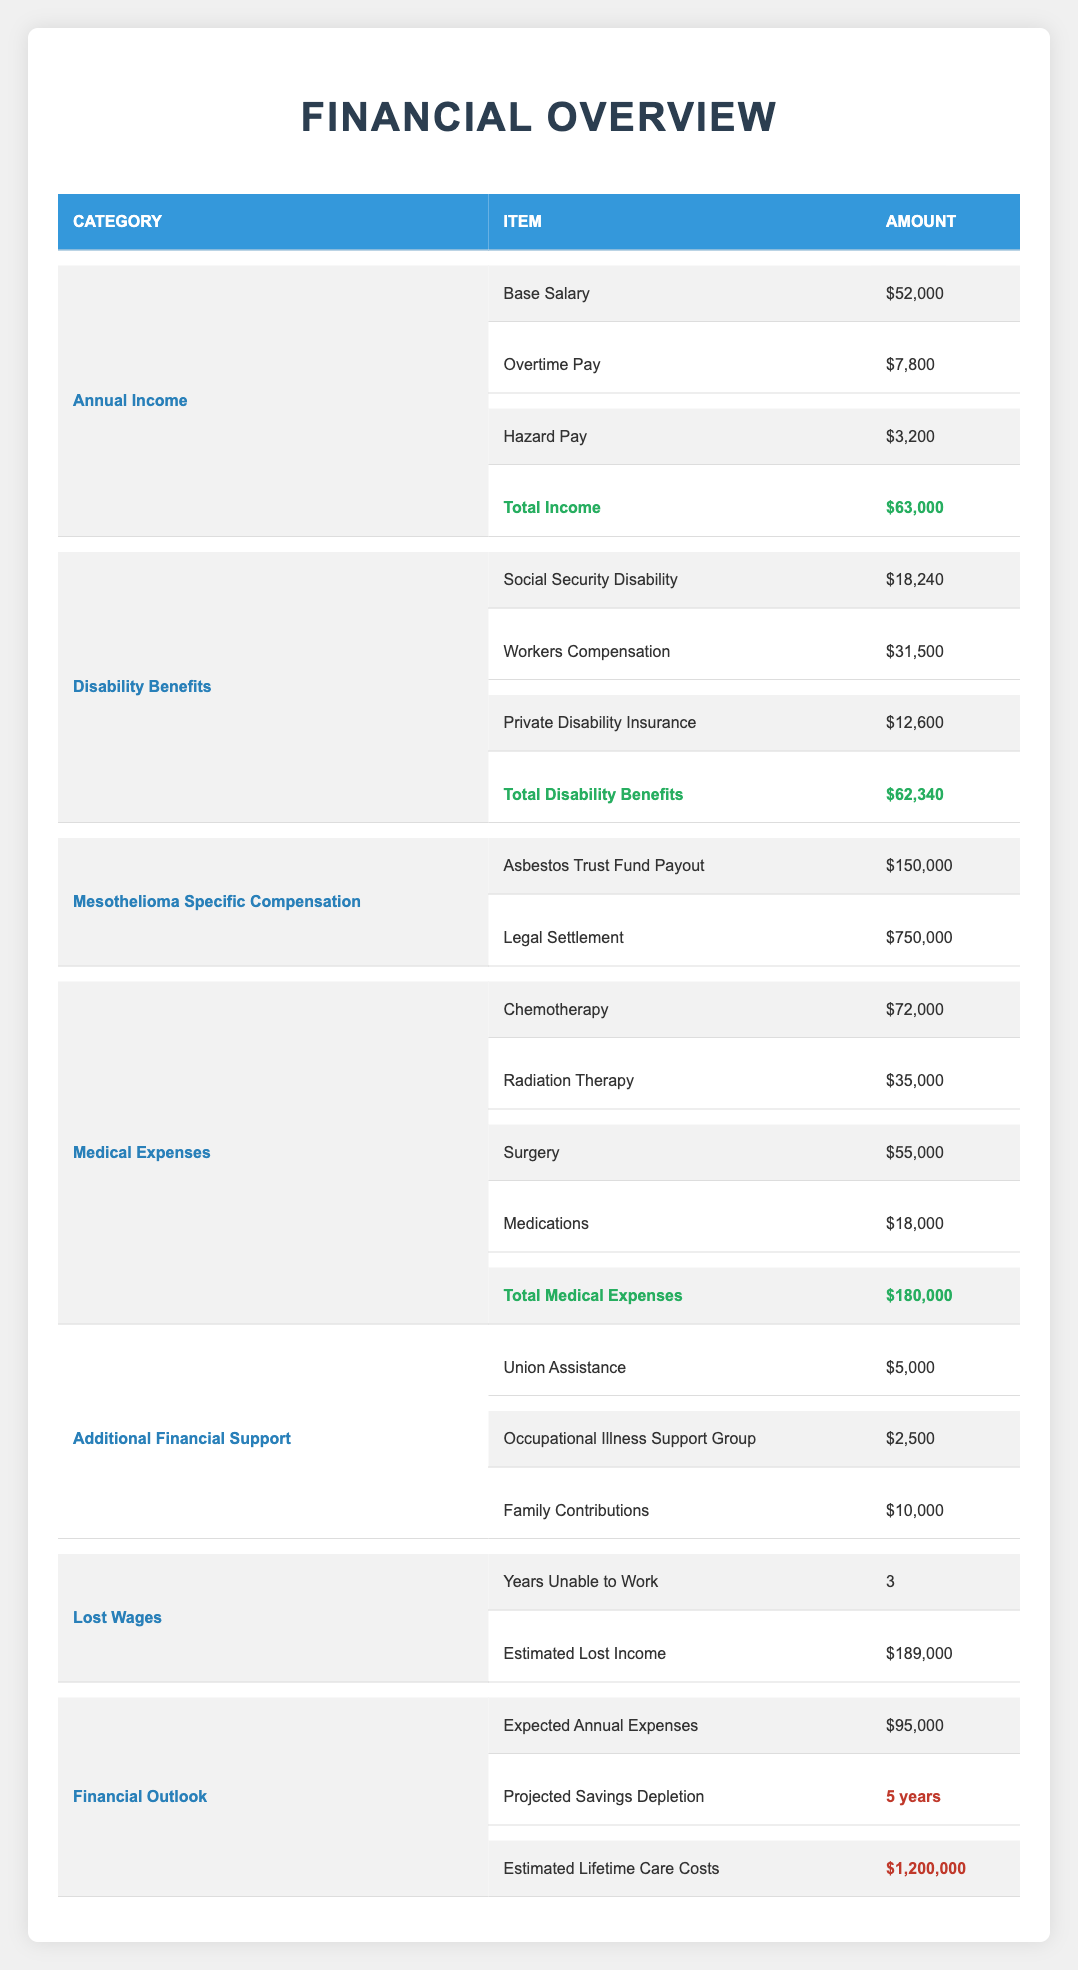What is the total annual income for the construction worker? The total annual income is stated clearly in the table under the Annual Income category as Total Income, which amounts to $63,000.
Answer: $63,000 What are the total disability benefits received by the construction worker? The total disability benefits are outlined in the Disability Benefits category under Total Disability Benefits, which amounts to $62,340.
Answer: $62,340 Is the sum of the asbestos trust fund payout and legal settlement greater than the total medical expenses? The asbestos trust fund payout is $150,000 and the legal settlement is $750,000. Summing them gives $900,000. The total medical expenses are $180,000. Since $900,000 is greater than $180,000, the answer is yes.
Answer: Yes What are the expected annual expenses compared to the total annual income? The expected annual expenses are $95,000 while the total income is $63,000. Comparing these figures shows that the expected expenses exceed the total income, meaning there is a shortfall.
Answer: The expected annual expenses exceed total income What is the estimated lifetime care cost? The estimated lifetime care costs are shown in the Financial Outlook section of the table, amounting to $1,200,000.
Answer: $1,200,000 How much financial support is received from family contributions? Family contributions are listed in the Additional Financial Support section as $10,000.
Answer: $10,000 What is the total amount of medical expenses incurred by the construction worker? The total medical expenses are clearly labeled in the Medical Expenses section as Total Medical Expenses, which amounts to $180,000.
Answer: $180,000 If the worker has been unable to work for 3 years, what is the estimated total lost income during that time? The estimated lost income is listed in the Lost Wages section as $189,000, indicating how much income was lost due to being unable to work for 3 years.
Answer: $189,000 Does the construction worker receive more from workers compensation than from social security disability? Workers compensation is $31,500, and social security disability is $18,240. Since $31,500 is greater than $18,240, the answer is yes.
Answer: Yes 